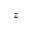<formula> <loc_0><loc_0><loc_500><loc_500>z</formula> 